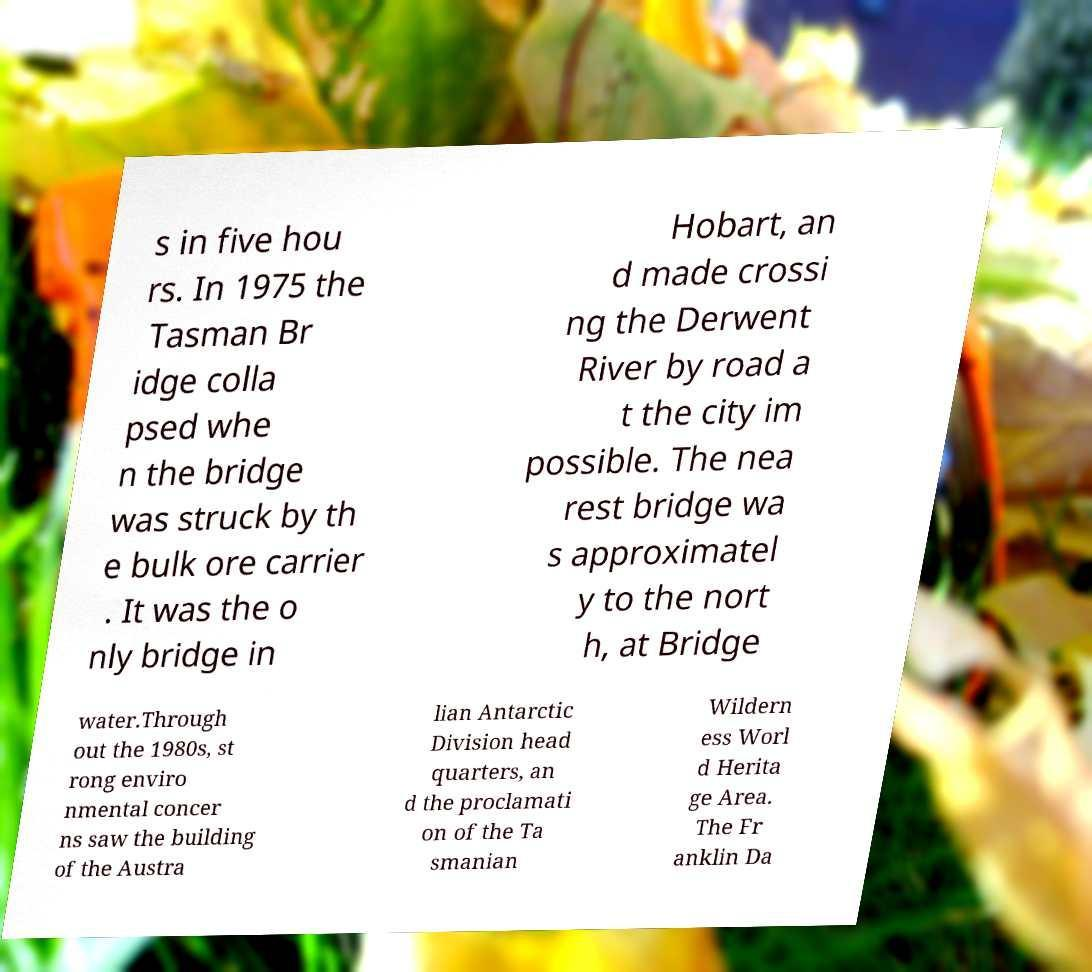Can you read and provide the text displayed in the image?This photo seems to have some interesting text. Can you extract and type it out for me? s in five hou rs. In 1975 the Tasman Br idge colla psed whe n the bridge was struck by th e bulk ore carrier . It was the o nly bridge in Hobart, an d made crossi ng the Derwent River by road a t the city im possible. The nea rest bridge wa s approximatel y to the nort h, at Bridge water.Through out the 1980s, st rong enviro nmental concer ns saw the building of the Austra lian Antarctic Division head quarters, an d the proclamati on of the Ta smanian Wildern ess Worl d Herita ge Area. The Fr anklin Da 